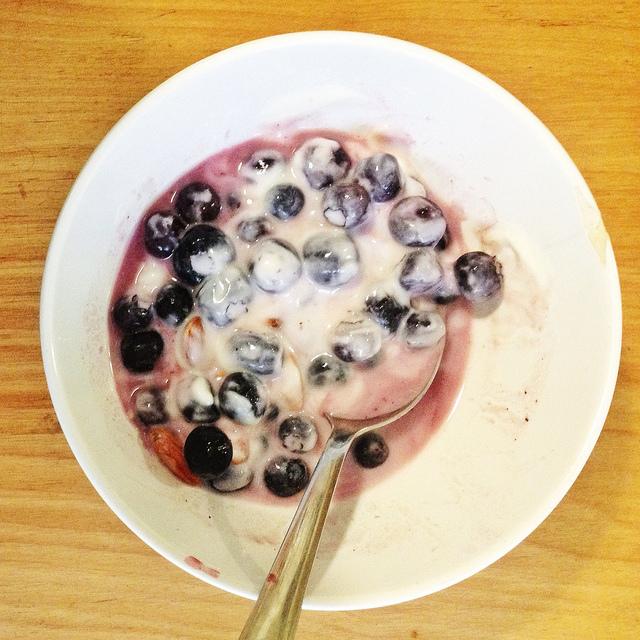What type of fruit is here?
Give a very brief answer. Blueberries. Is this something you would eat for dinner?
Quick response, please. No. What color is the bowl?
Keep it brief. White. 